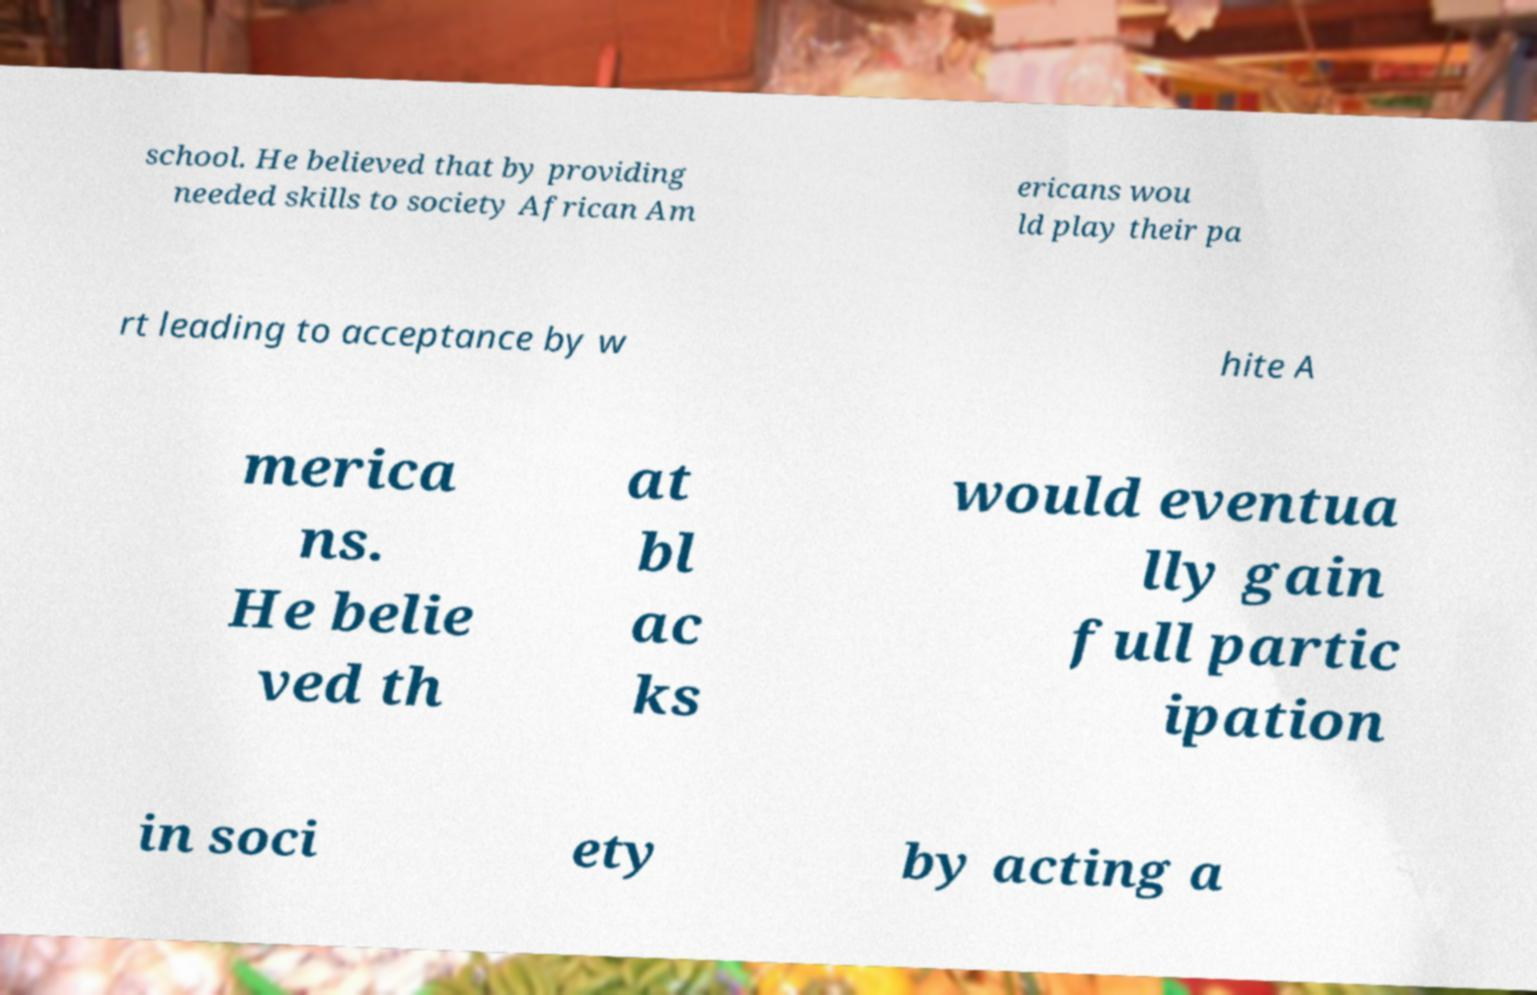Please read and relay the text visible in this image. What does it say? school. He believed that by providing needed skills to society African Am ericans wou ld play their pa rt leading to acceptance by w hite A merica ns. He belie ved th at bl ac ks would eventua lly gain full partic ipation in soci ety by acting a 